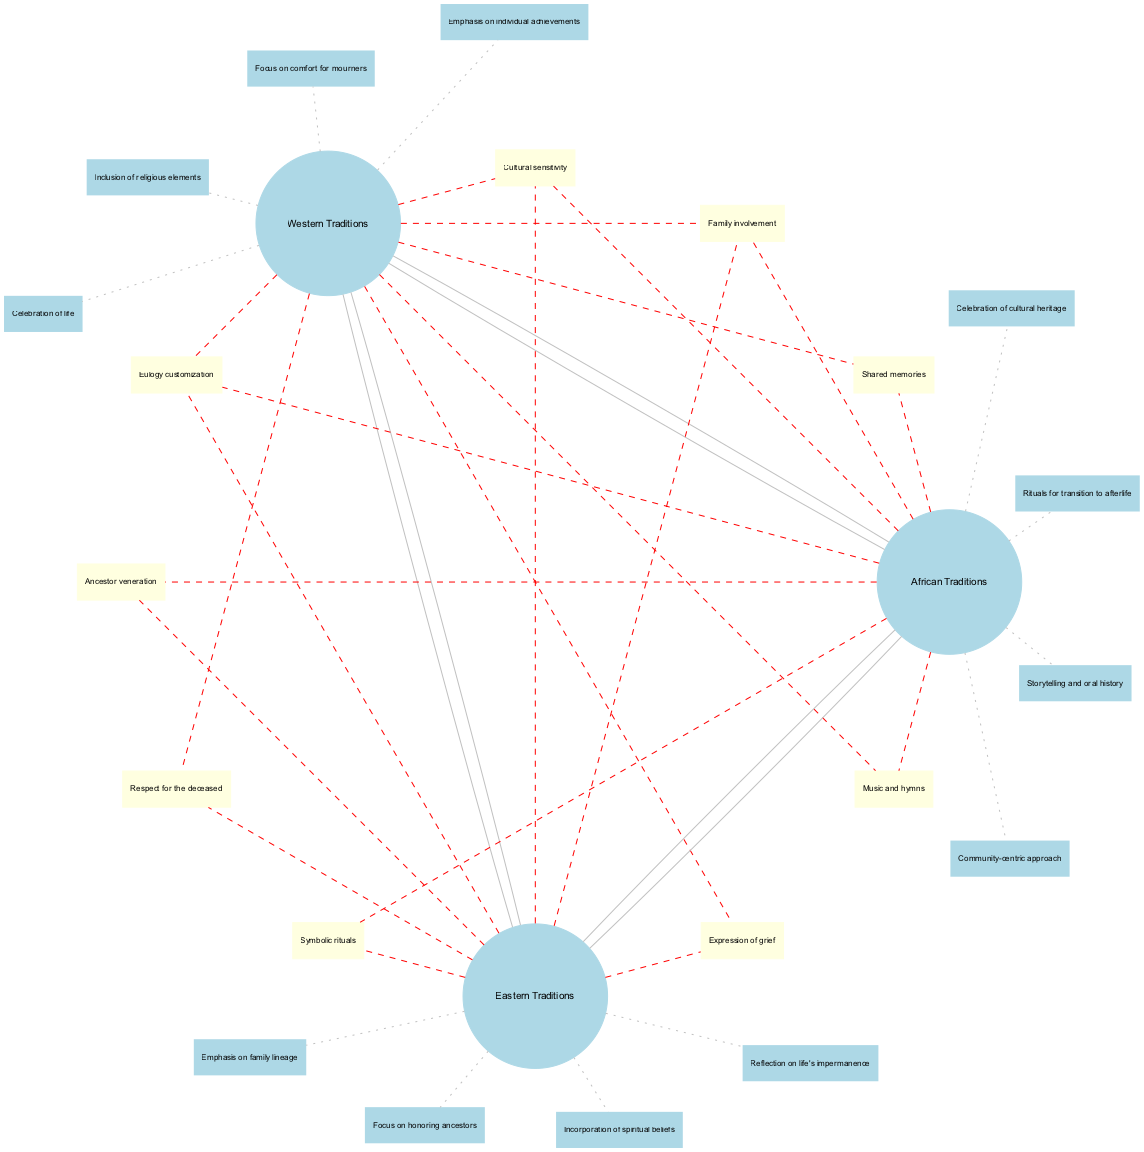What elements are unique to Western Traditions? The Western Traditions set lists specific elements such as "Emphasis on individual achievements," "Focus on comfort for mourners," "Inclusion of religious elements," and "Celebration of life." Each of these elements is found only within the Western Traditions set and not in the others.
Answer: Emphasis on individual achievements, focus on comfort for mourners, inclusion of religious elements, celebration of life What do Western and Eastern Traditions share? The intersection between Western and Eastern Traditions includes the elements "Expression of grief" and "Respect for the deceased." This indicates that these two cultural traditions have some common ground regarding how they honor and express emotions surrounding death.
Answer: Expression of grief, respect for the deceased How many total elements are included in the African Traditions set? The African Traditions set contains four distinct elements: "Community-centric approach," "Storytelling and oral history," "Rituals for transition to afterlife," and "Celebration of cultural heritage." Therefore, when counting these elements, the total comes to four.
Answer: 4 What elements do all three traditions have in common? The intersection that includes all three sets—Western, Eastern, and African Traditions—contains the elements "Eulogy customization," "Cultural sensitivity," and "Family involvement." These shared elements point to common practices in crafting eulogies across the different cultural traditions.
Answer: Eulogy customization, cultural sensitivity, family involvement Which two traditions incorporate ancestor veneration? The intersection connecting Eastern and African Traditions indicates the shared element "Ancestor veneration." This suggests that both cultures honor their ancestors in their funeral traditions, highlighting a significant cultural practice associated with death.
Answer: Eastern Traditions, African Traditions 